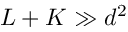Convert formula to latex. <formula><loc_0><loc_0><loc_500><loc_500>L + K \gg d ^ { 2 }</formula> 